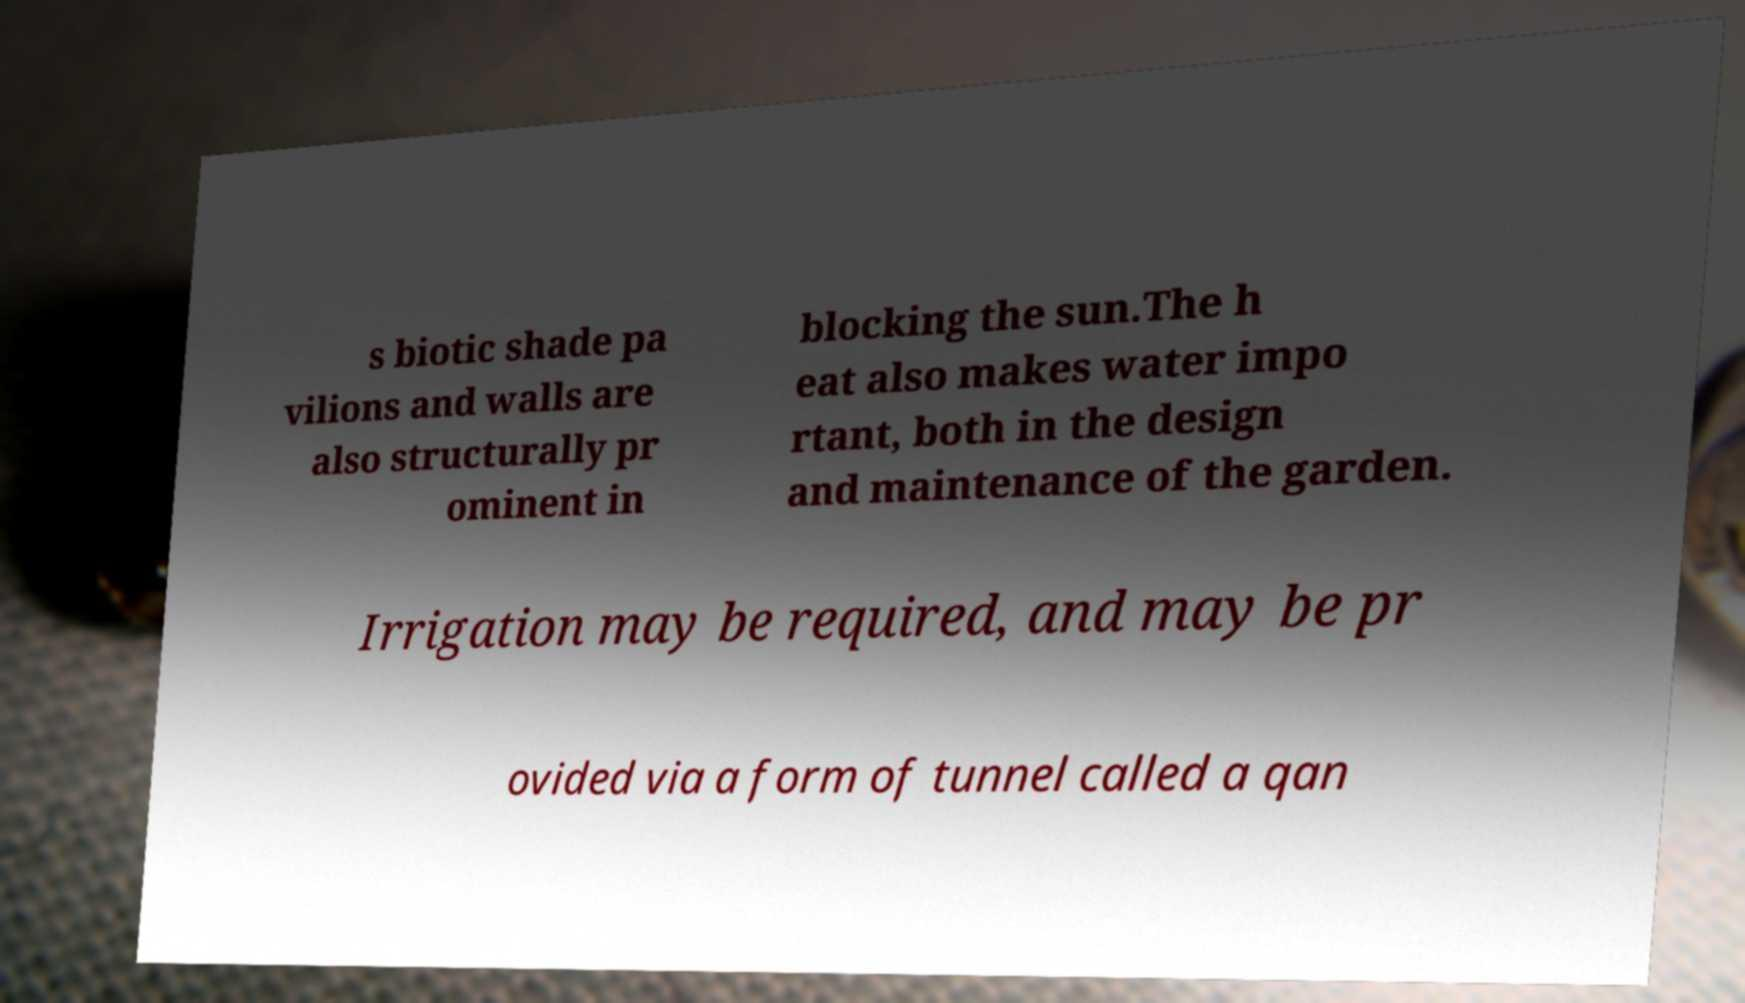Can you read and provide the text displayed in the image?This photo seems to have some interesting text. Can you extract and type it out for me? s biotic shade pa vilions and walls are also structurally pr ominent in blocking the sun.The h eat also makes water impo rtant, both in the design and maintenance of the garden. Irrigation may be required, and may be pr ovided via a form of tunnel called a qan 